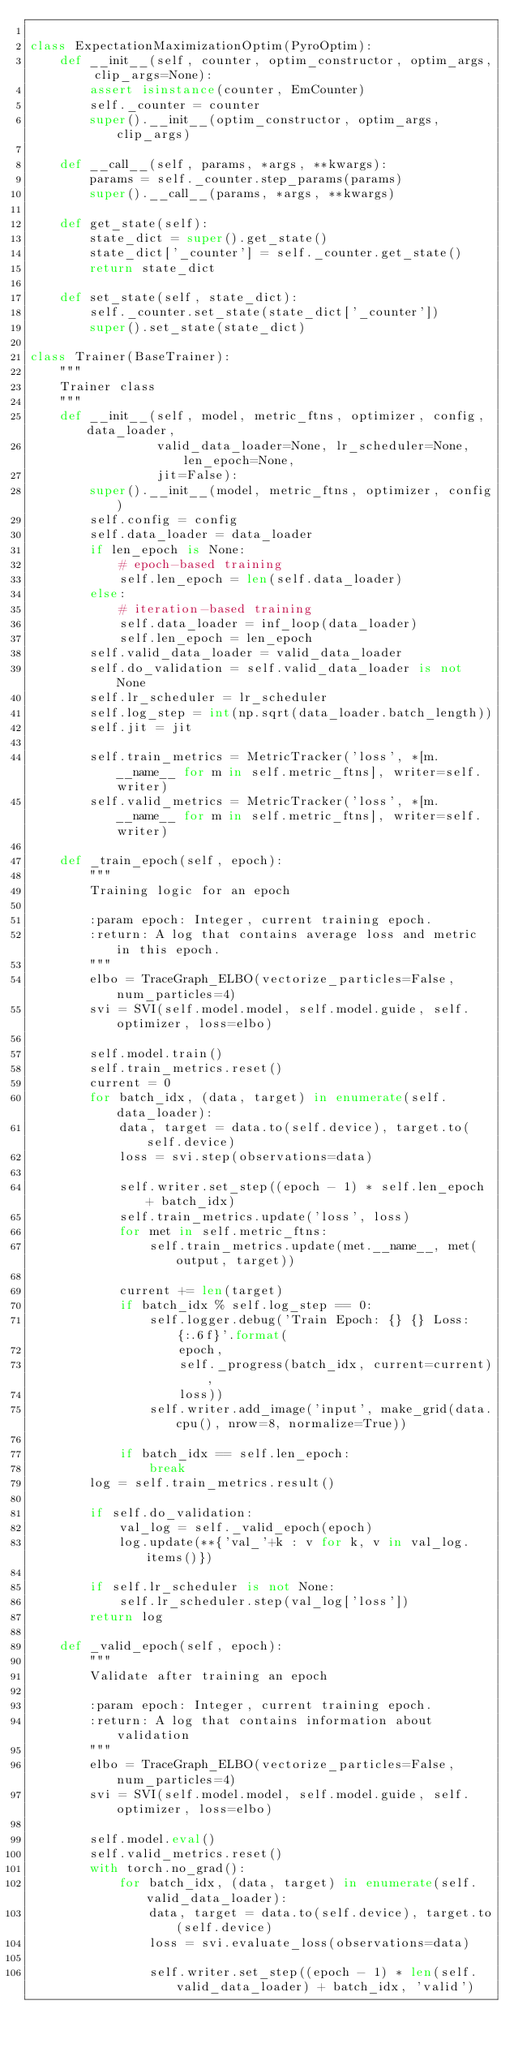Convert code to text. <code><loc_0><loc_0><loc_500><loc_500><_Python_>
class ExpectationMaximizationOptim(PyroOptim):
    def __init__(self, counter, optim_constructor, optim_args, clip_args=None):
        assert isinstance(counter, EmCounter)
        self._counter = counter
        super().__init__(optim_constructor, optim_args, clip_args)

    def __call__(self, params, *args, **kwargs):
        params = self._counter.step_params(params)
        super().__call__(params, *args, **kwargs)

    def get_state(self):
        state_dict = super().get_state()
        state_dict['_counter'] = self._counter.get_state()
        return state_dict

    def set_state(self, state_dict):
        self._counter.set_state(state_dict['_counter'])
        super().set_state(state_dict)

class Trainer(BaseTrainer):
    """
    Trainer class
    """
    def __init__(self, model, metric_ftns, optimizer, config, data_loader,
                 valid_data_loader=None, lr_scheduler=None, len_epoch=None,
                 jit=False):
        super().__init__(model, metric_ftns, optimizer, config)
        self.config = config
        self.data_loader = data_loader
        if len_epoch is None:
            # epoch-based training
            self.len_epoch = len(self.data_loader)
        else:
            # iteration-based training
            self.data_loader = inf_loop(data_loader)
            self.len_epoch = len_epoch
        self.valid_data_loader = valid_data_loader
        self.do_validation = self.valid_data_loader is not None
        self.lr_scheduler = lr_scheduler
        self.log_step = int(np.sqrt(data_loader.batch_length))
        self.jit = jit

        self.train_metrics = MetricTracker('loss', *[m.__name__ for m in self.metric_ftns], writer=self.writer)
        self.valid_metrics = MetricTracker('loss', *[m.__name__ for m in self.metric_ftns], writer=self.writer)

    def _train_epoch(self, epoch):
        """
        Training logic for an epoch

        :param epoch: Integer, current training epoch.
        :return: A log that contains average loss and metric in this epoch.
        """
        elbo = TraceGraph_ELBO(vectorize_particles=False, num_particles=4)
        svi = SVI(self.model.model, self.model.guide, self.optimizer, loss=elbo)

        self.model.train()
        self.train_metrics.reset()
        current = 0
        for batch_idx, (data, target) in enumerate(self.data_loader):
            data, target = data.to(self.device), target.to(self.device)
            loss = svi.step(observations=data)

            self.writer.set_step((epoch - 1) * self.len_epoch + batch_idx)
            self.train_metrics.update('loss', loss)
            for met in self.metric_ftns:
                self.train_metrics.update(met.__name__, met(output, target))

            current += len(target)
            if batch_idx % self.log_step == 0:
                self.logger.debug('Train Epoch: {} {} Loss: {:.6f}'.format(
                    epoch,
                    self._progress(batch_idx, current=current),
                    loss))
                self.writer.add_image('input', make_grid(data.cpu(), nrow=8, normalize=True))

            if batch_idx == self.len_epoch:
                break
        log = self.train_metrics.result()

        if self.do_validation:
            val_log = self._valid_epoch(epoch)
            log.update(**{'val_'+k : v for k, v in val_log.items()})

        if self.lr_scheduler is not None:
            self.lr_scheduler.step(val_log['loss'])
        return log

    def _valid_epoch(self, epoch):
        """
        Validate after training an epoch

        :param epoch: Integer, current training epoch.
        :return: A log that contains information about validation
        """
        elbo = TraceGraph_ELBO(vectorize_particles=False, num_particles=4)
        svi = SVI(self.model.model, self.model.guide, self.optimizer, loss=elbo)

        self.model.eval()
        self.valid_metrics.reset()
        with torch.no_grad():
            for batch_idx, (data, target) in enumerate(self.valid_data_loader):
                data, target = data.to(self.device), target.to(self.device)
                loss = svi.evaluate_loss(observations=data)

                self.writer.set_step((epoch - 1) * len(self.valid_data_loader) + batch_idx, 'valid')</code> 